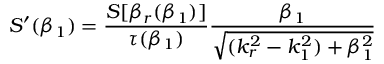Convert formula to latex. <formula><loc_0><loc_0><loc_500><loc_500>S ^ { \prime } ( \beta _ { 1 } ) = \frac { S [ \beta _ { r } ( \beta _ { 1 } ) ] } { \tau ( \beta _ { 1 } ) } \frac { \beta _ { 1 } } { \sqrt { ( k _ { r } ^ { 2 } - k _ { 1 } ^ { 2 } ) + \beta _ { 1 } ^ { 2 } } }</formula> 